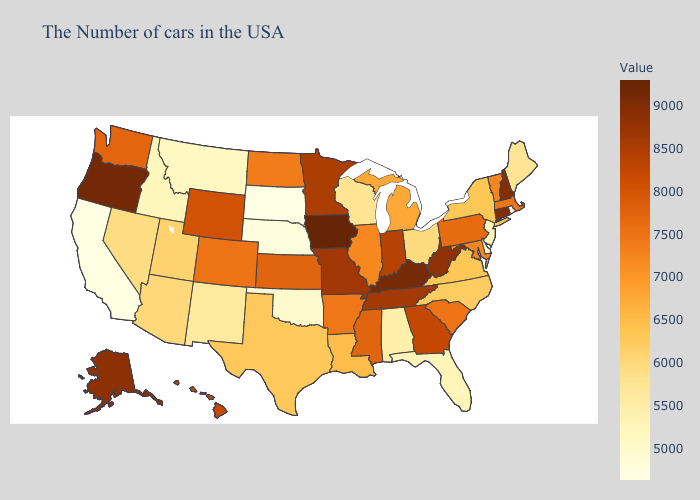Does the map have missing data?
Short answer required. No. Does North Dakota have the lowest value in the USA?
Concise answer only. No. Does the map have missing data?
Write a very short answer. No. Does Maine have the lowest value in the Northeast?
Short answer required. No. Does the map have missing data?
Give a very brief answer. No. 